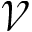<formula> <loc_0><loc_0><loc_500><loc_500>\mathcal { V }</formula> 